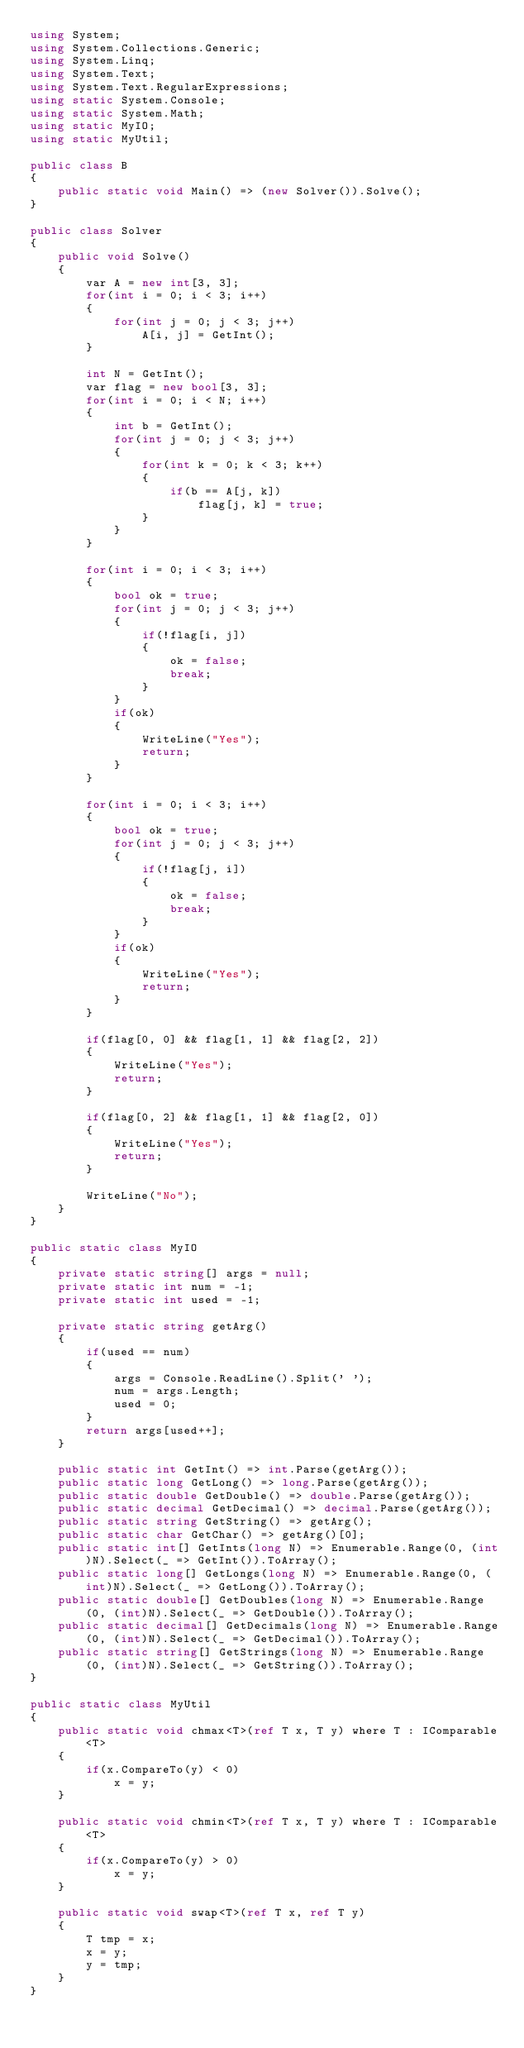<code> <loc_0><loc_0><loc_500><loc_500><_C#_>using System;
using System.Collections.Generic;
using System.Linq;
using System.Text;
using System.Text.RegularExpressions;
using static System.Console;
using static System.Math;
using static MyIO;
using static MyUtil;

public class B
{
	public static void Main() => (new Solver()).Solve();
}

public class Solver
{
	public void Solve()
	{
		var A = new int[3, 3];
		for(int i = 0; i < 3; i++)
		{
			for(int j = 0; j < 3; j++)
				A[i, j] = GetInt();
		}

		int N = GetInt();
		var flag = new bool[3, 3];
		for(int i = 0; i < N; i++)
		{
			int b = GetInt();
			for(int j = 0; j < 3; j++)
			{
				for(int k = 0; k < 3; k++)
				{
					if(b == A[j, k])
						flag[j, k] = true;
				}
			}
		}

		for(int i = 0; i < 3; i++)
		{
			bool ok = true;
			for(int j = 0; j < 3; j++)
			{
				if(!flag[i, j])
				{
					ok = false;
					break;
				}
			}
			if(ok)
			{
				WriteLine("Yes");
				return;
			}
		}

		for(int i = 0; i < 3; i++)
		{
			bool ok = true;
			for(int j = 0; j < 3; j++)
			{
				if(!flag[j, i])
				{
					ok = false;
					break;
				}
			}
			if(ok)
			{
				WriteLine("Yes");
				return;
			}
		}

		if(flag[0, 0] && flag[1, 1] && flag[2, 2])
		{
			WriteLine("Yes");
			return;
		}

		if(flag[0, 2] && flag[1, 1] && flag[2, 0])
		{
			WriteLine("Yes");
			return;
		}

		WriteLine("No");
	}
}

public static class MyIO
{
	private static string[] args = null;
	private static int num = -1;
	private static int used = -1;

	private static string getArg()
	{
		if(used == num)
		{
			args = Console.ReadLine().Split(' ');
			num = args.Length;
			used = 0;
		}
		return args[used++];
	}

	public static int GetInt() => int.Parse(getArg());
	public static long GetLong() => long.Parse(getArg());
	public static double GetDouble() => double.Parse(getArg());
	public static decimal GetDecimal() => decimal.Parse(getArg());
	public static string GetString() => getArg();
	public static char GetChar() => getArg()[0];
	public static int[] GetInts(long N) => Enumerable.Range(0, (int)N).Select(_ => GetInt()).ToArray();
	public static long[] GetLongs(long N) => Enumerable.Range(0, (int)N).Select(_ => GetLong()).ToArray();
	public static double[] GetDoubles(long N) => Enumerable.Range(0, (int)N).Select(_ => GetDouble()).ToArray();
	public static decimal[] GetDecimals(long N) => Enumerable.Range(0, (int)N).Select(_ => GetDecimal()).ToArray();
	public static string[] GetStrings(long N) => Enumerable.Range(0, (int)N).Select(_ => GetString()).ToArray();
}

public static class MyUtil
{
	public static void chmax<T>(ref T x, T y) where T : IComparable<T>
	{
		if(x.CompareTo(y) < 0)
			x = y;
	}

	public static void chmin<T>(ref T x, T y) where T : IComparable<T>
	{
		if(x.CompareTo(y) > 0)
			x = y;
	}

	public static void swap<T>(ref T x, ref T y)
	{
		T tmp = x;
		x = y;
		y = tmp;
	}
}</code> 